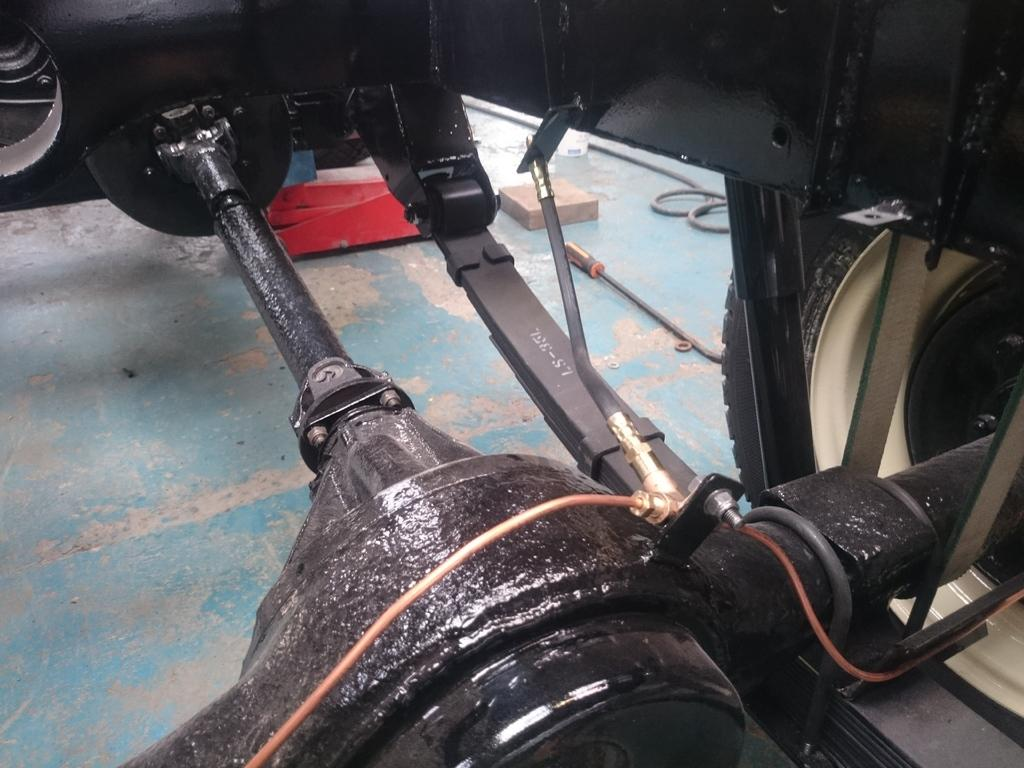What type of object is depicted in the image? The image contains parts of a vehicle. Can you describe any additional items in the image? There is a tool present in the image. What flavor of cakes can be seen in the image? There are no cakes present in the image; it features parts of a vehicle and a tool. 